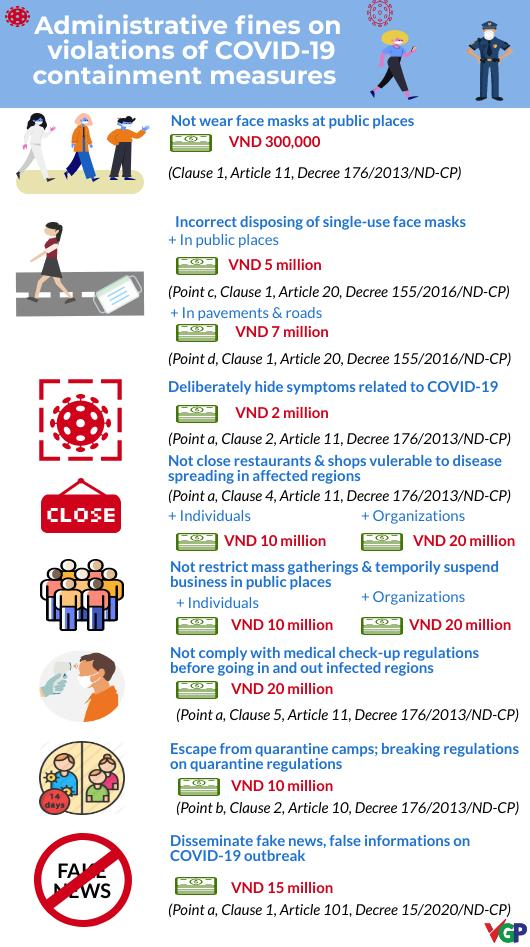Mention a couple of crucial points in this snapshot. In public places and on pavements and roads, the fine for improperly disposing of single-use face masks is VND 12 million. The number of coronavirus icons displayed is five. There are 11 currency icons displayed. 